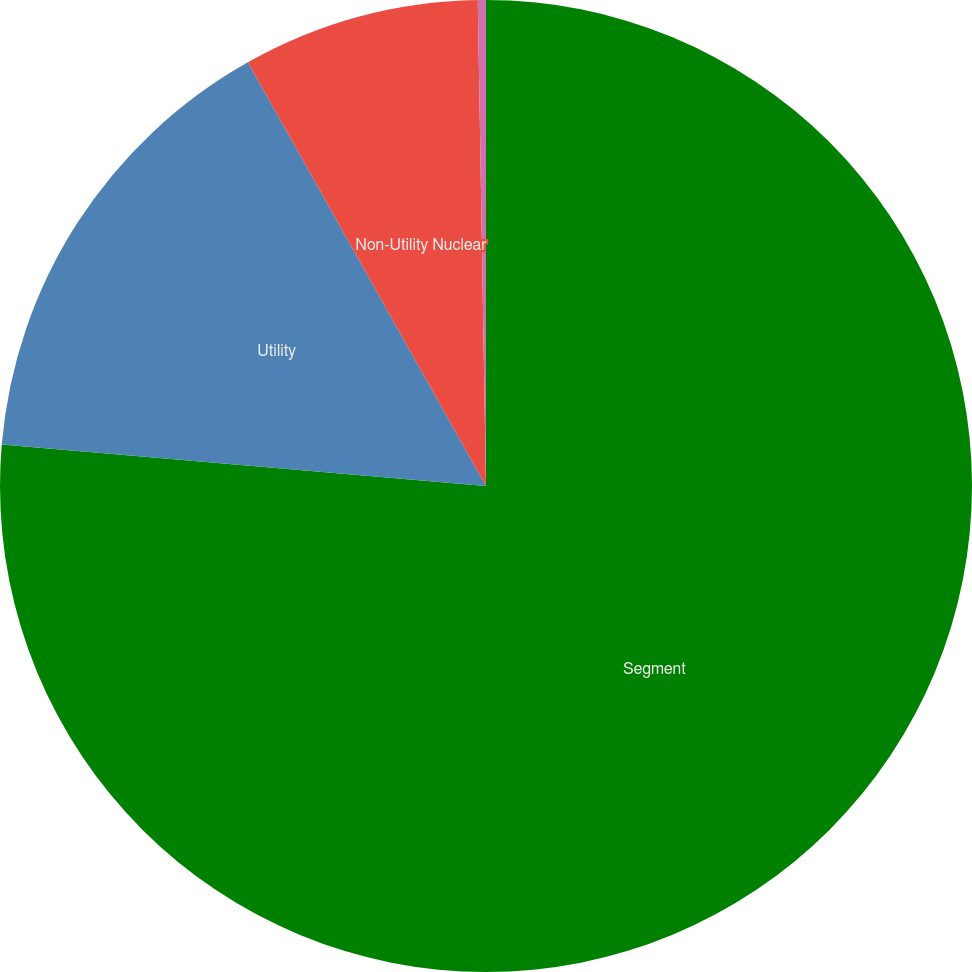Convert chart to OTSL. <chart><loc_0><loc_0><loc_500><loc_500><pie_chart><fcel>Segment<fcel>Utility<fcel>Non-Utility Nuclear<fcel>Parent Company & Other<nl><fcel>76.37%<fcel>15.49%<fcel>7.88%<fcel>0.27%<nl></chart> 